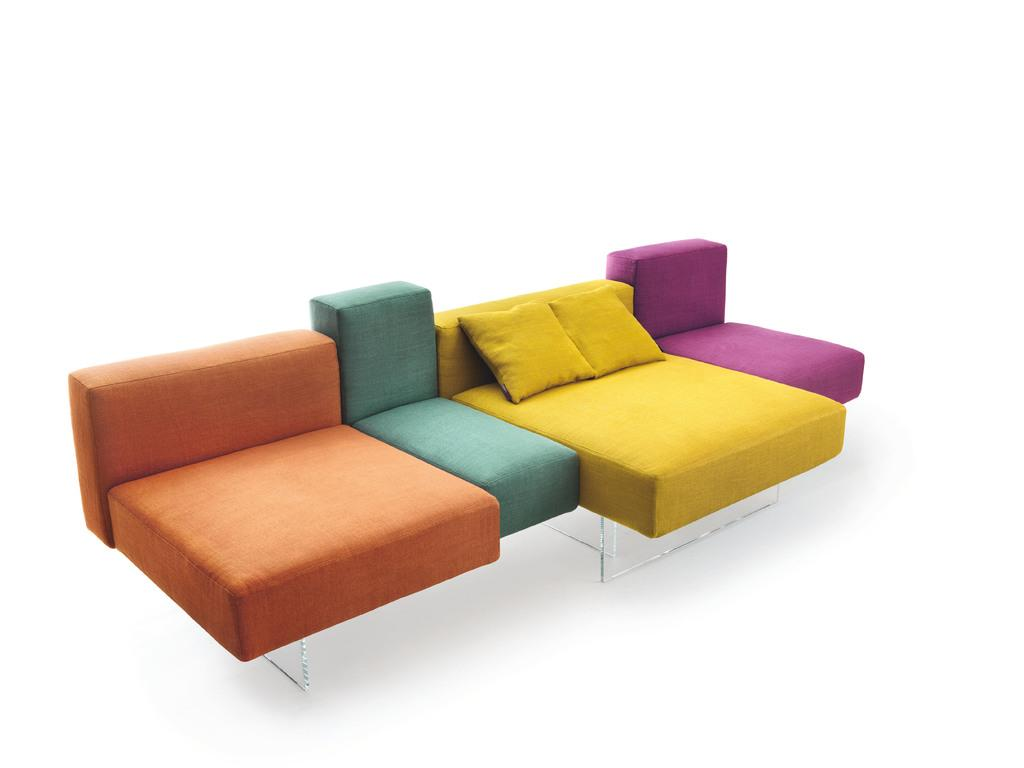What type of furniture is present in the image? There is a couch in the image. What can be seen on the couch? There are pillows in the image. What colors are the couch and pillows? The couch and pillows are in different colors, including orange, blue, yellow, and purple. What type of nation is represented by the pillows in the image? There is no nation represented by the pillows in the image; they are simply pillows in different colors. 